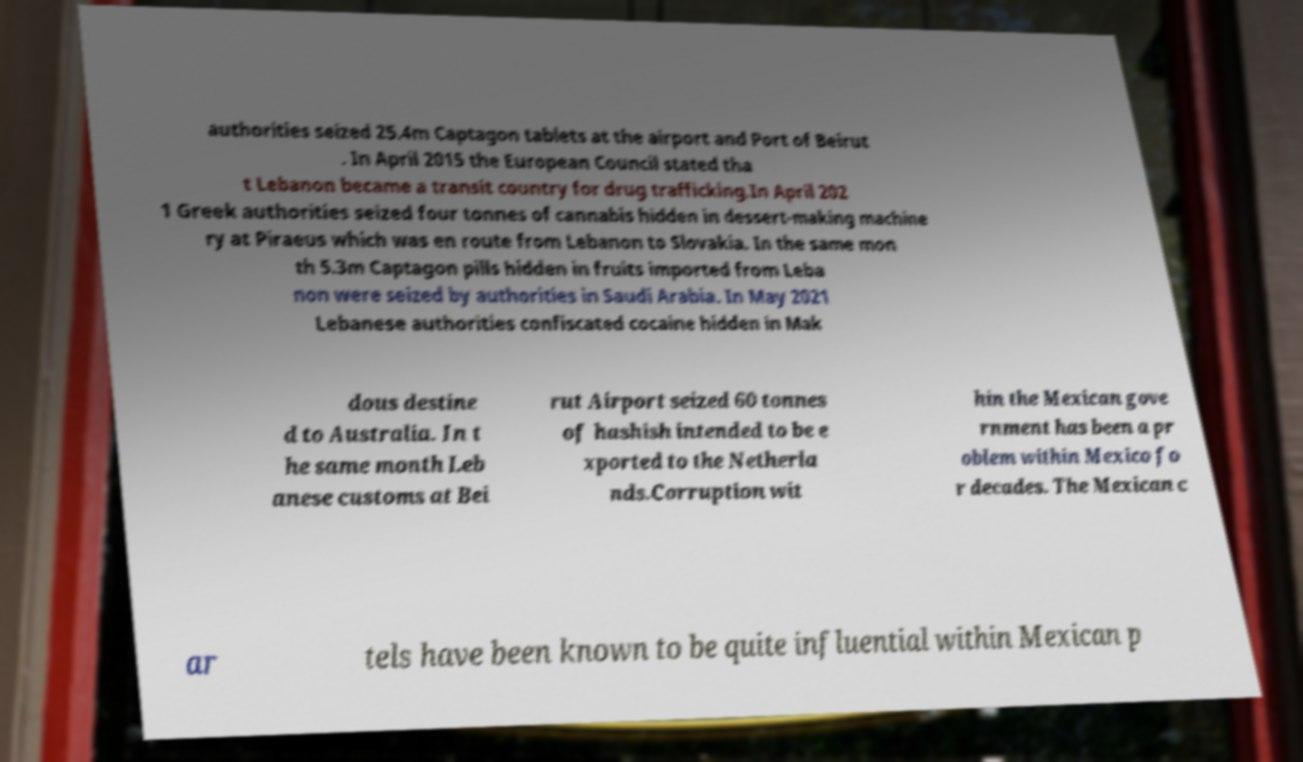Could you assist in decoding the text presented in this image and type it out clearly? authorities seized 25.4m Captagon tablets at the airport and Port of Beirut . In April 2015 the European Council stated tha t Lebanon became a transit country for drug trafficking.In April 202 1 Greek authorities seized four tonnes of cannabis hidden in dessert-making machine ry at Piraeus which was en route from Lebanon to Slovakia. In the same mon th 5.3m Captagon pills hidden in fruits imported from Leba non were seized by authorities in Saudi Arabia. In May 2021 Lebanese authorities confiscated cocaine hidden in Mak dous destine d to Australia. In t he same month Leb anese customs at Bei rut Airport seized 60 tonnes of hashish intended to be e xported to the Netherla nds.Corruption wit hin the Mexican gove rnment has been a pr oblem within Mexico fo r decades. The Mexican c ar tels have been known to be quite influential within Mexican p 